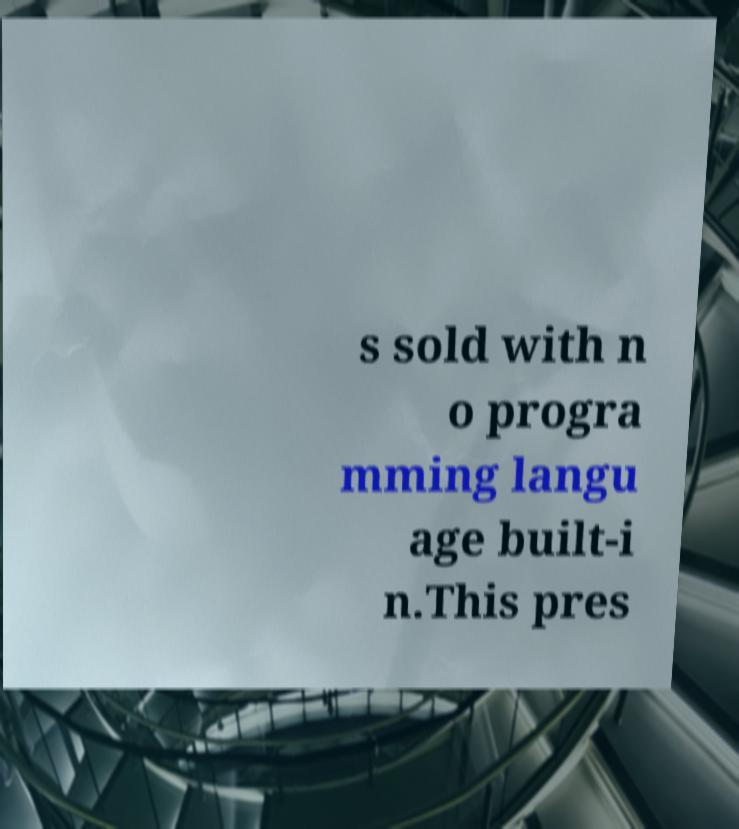Can you read and provide the text displayed in the image?This photo seems to have some interesting text. Can you extract and type it out for me? s sold with n o progra mming langu age built-i n.This pres 